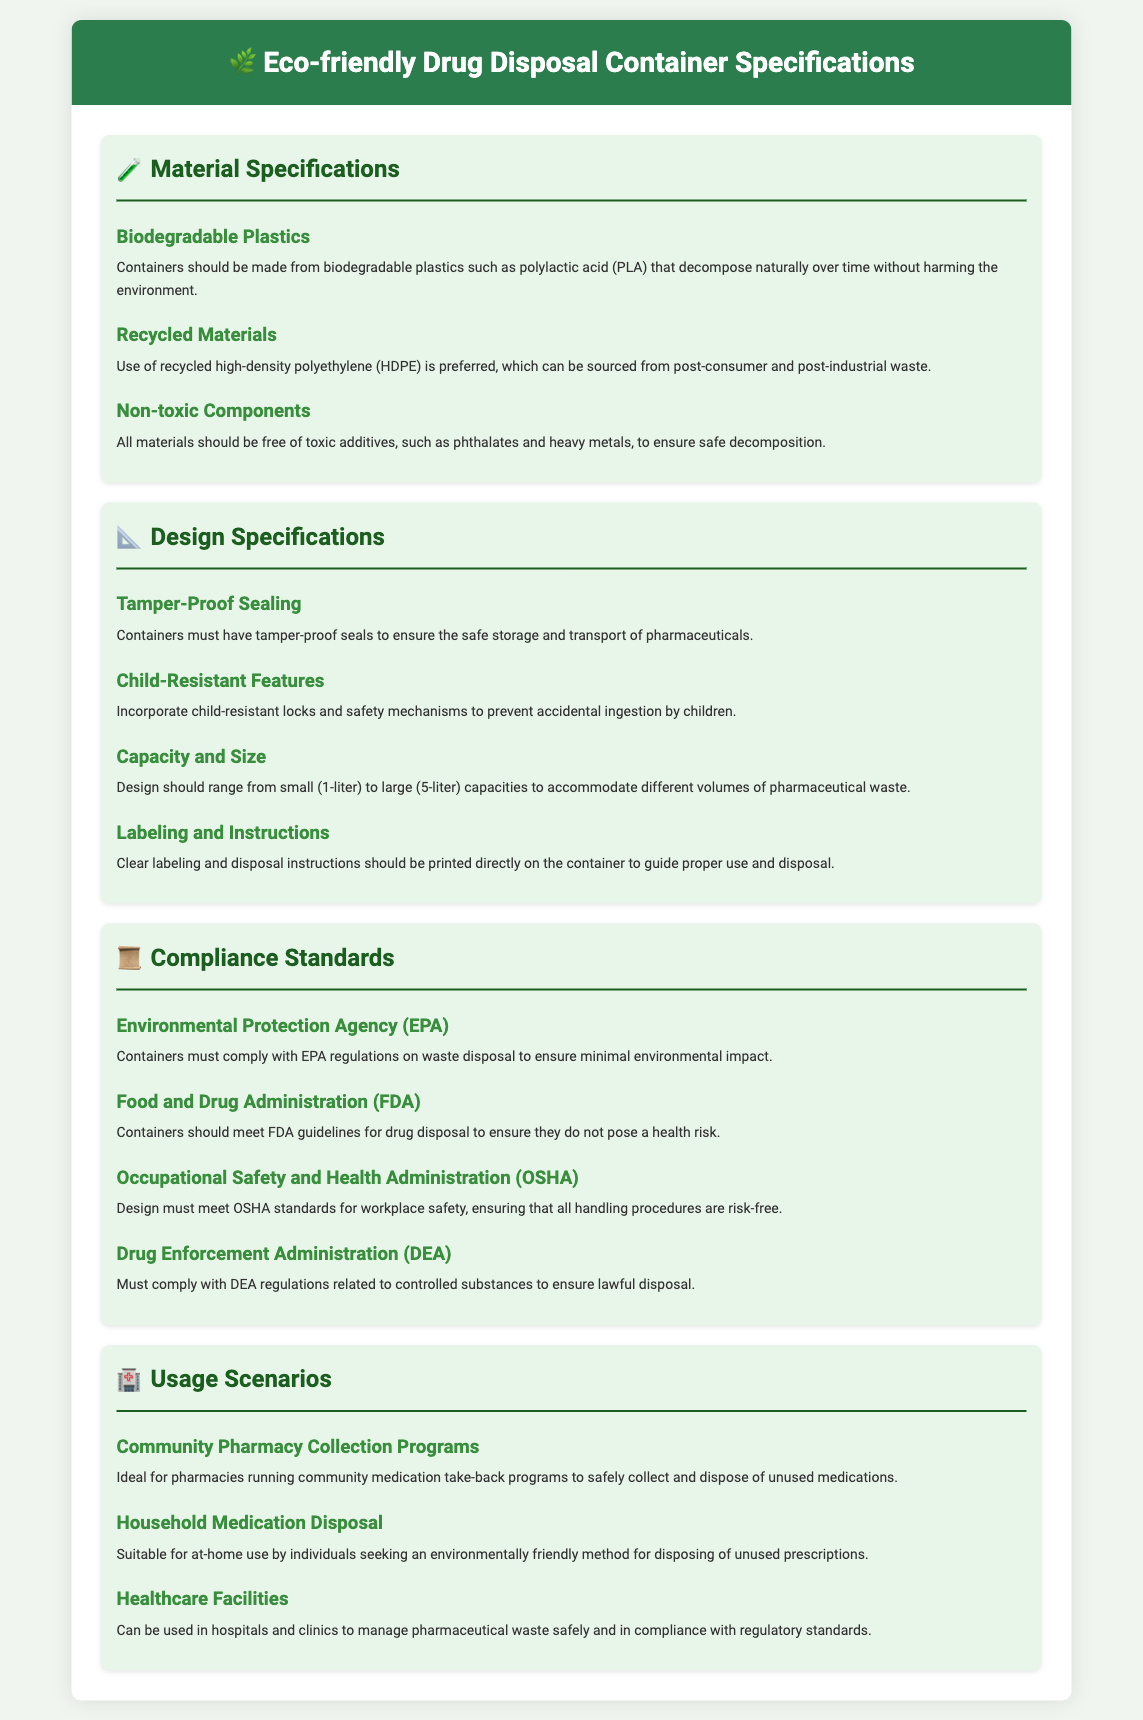What material is preferred for the containers? The preferred material for the containers is recycled high-density polyethylene sourced from post-consumer and post-industrial waste.
Answer: Recycled high-density polyethylene What are the child-resistant features designed to prevent? The child-resistant features are designed to prevent accidental ingestion by children.
Answer: Accidental ingestion What is the capacity range of the containers? The capacity range of the containers is from small (1-liter) to large (5-liter).
Answer: 1-liter to 5-liter Which compliance standard ensures minimal environmental impact? The compliance standard ensuring minimal environmental impact is the Environmental Protection Agency (EPA).
Answer: Environmental Protection Agency What should containers be free from? Containers should be free from toxic additives such as phthalates and heavy metals.
Answer: Toxic additives What are the suitable usage scenarios for community pharmacy collection programs? The suitable usage scenario for community pharmacy collection programs is to safely collect and dispose of unused medications.
Answer: Safely collect and dispose of unused medications What is the design requirement for containers regarding sealing? Containers must have tamper-proof seals to ensure safe storage and transport of pharmaceuticals.
Answer: Tamper-proof seals Which regulatory body regulates controlled substances disposal? The regulatory body that regulates controlled substances disposal is the Drug Enforcement Administration (DEA).
Answer: Drug Enforcement Administration What should be printed directly on the container to guide users? Clear labeling and disposal instructions should be printed directly on the container.
Answer: Clear labeling and disposal instructions 